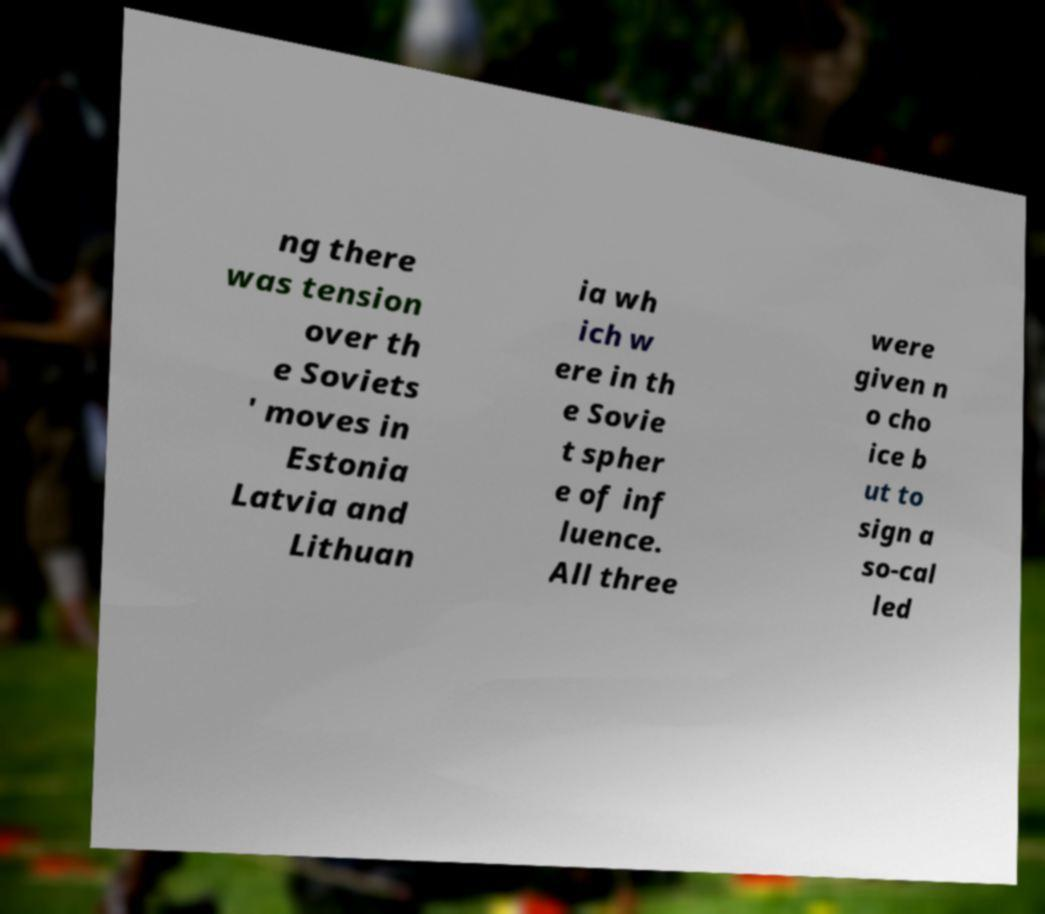I need the written content from this picture converted into text. Can you do that? ng there was tension over th e Soviets ' moves in Estonia Latvia and Lithuan ia wh ich w ere in th e Sovie t spher e of inf luence. All three were given n o cho ice b ut to sign a so-cal led 